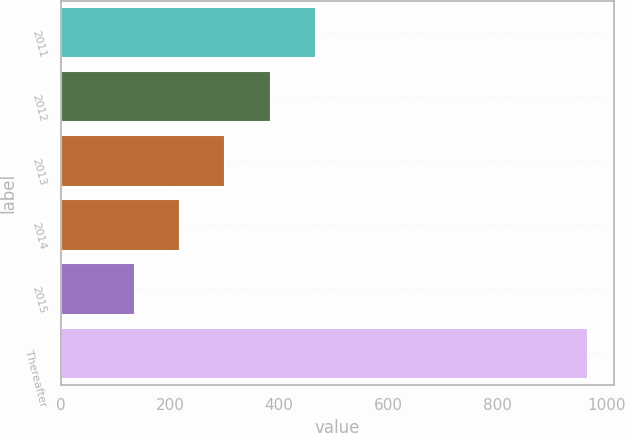Convert chart. <chart><loc_0><loc_0><loc_500><loc_500><bar_chart><fcel>2011<fcel>2012<fcel>2013<fcel>2014<fcel>2015<fcel>Thereafter<nl><fcel>467.6<fcel>384.7<fcel>301.8<fcel>218.9<fcel>136<fcel>965<nl></chart> 